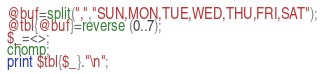Convert code to text. <code><loc_0><loc_0><loc_500><loc_500><_Perl_>@buf=split(",","SUN,MON,TUE,WED,THU,FRI,SAT");
@tbl{@buf}=reverse (0..7);
$_=<>;
chomp;
print $tbl{$_}."\n";
</code> 